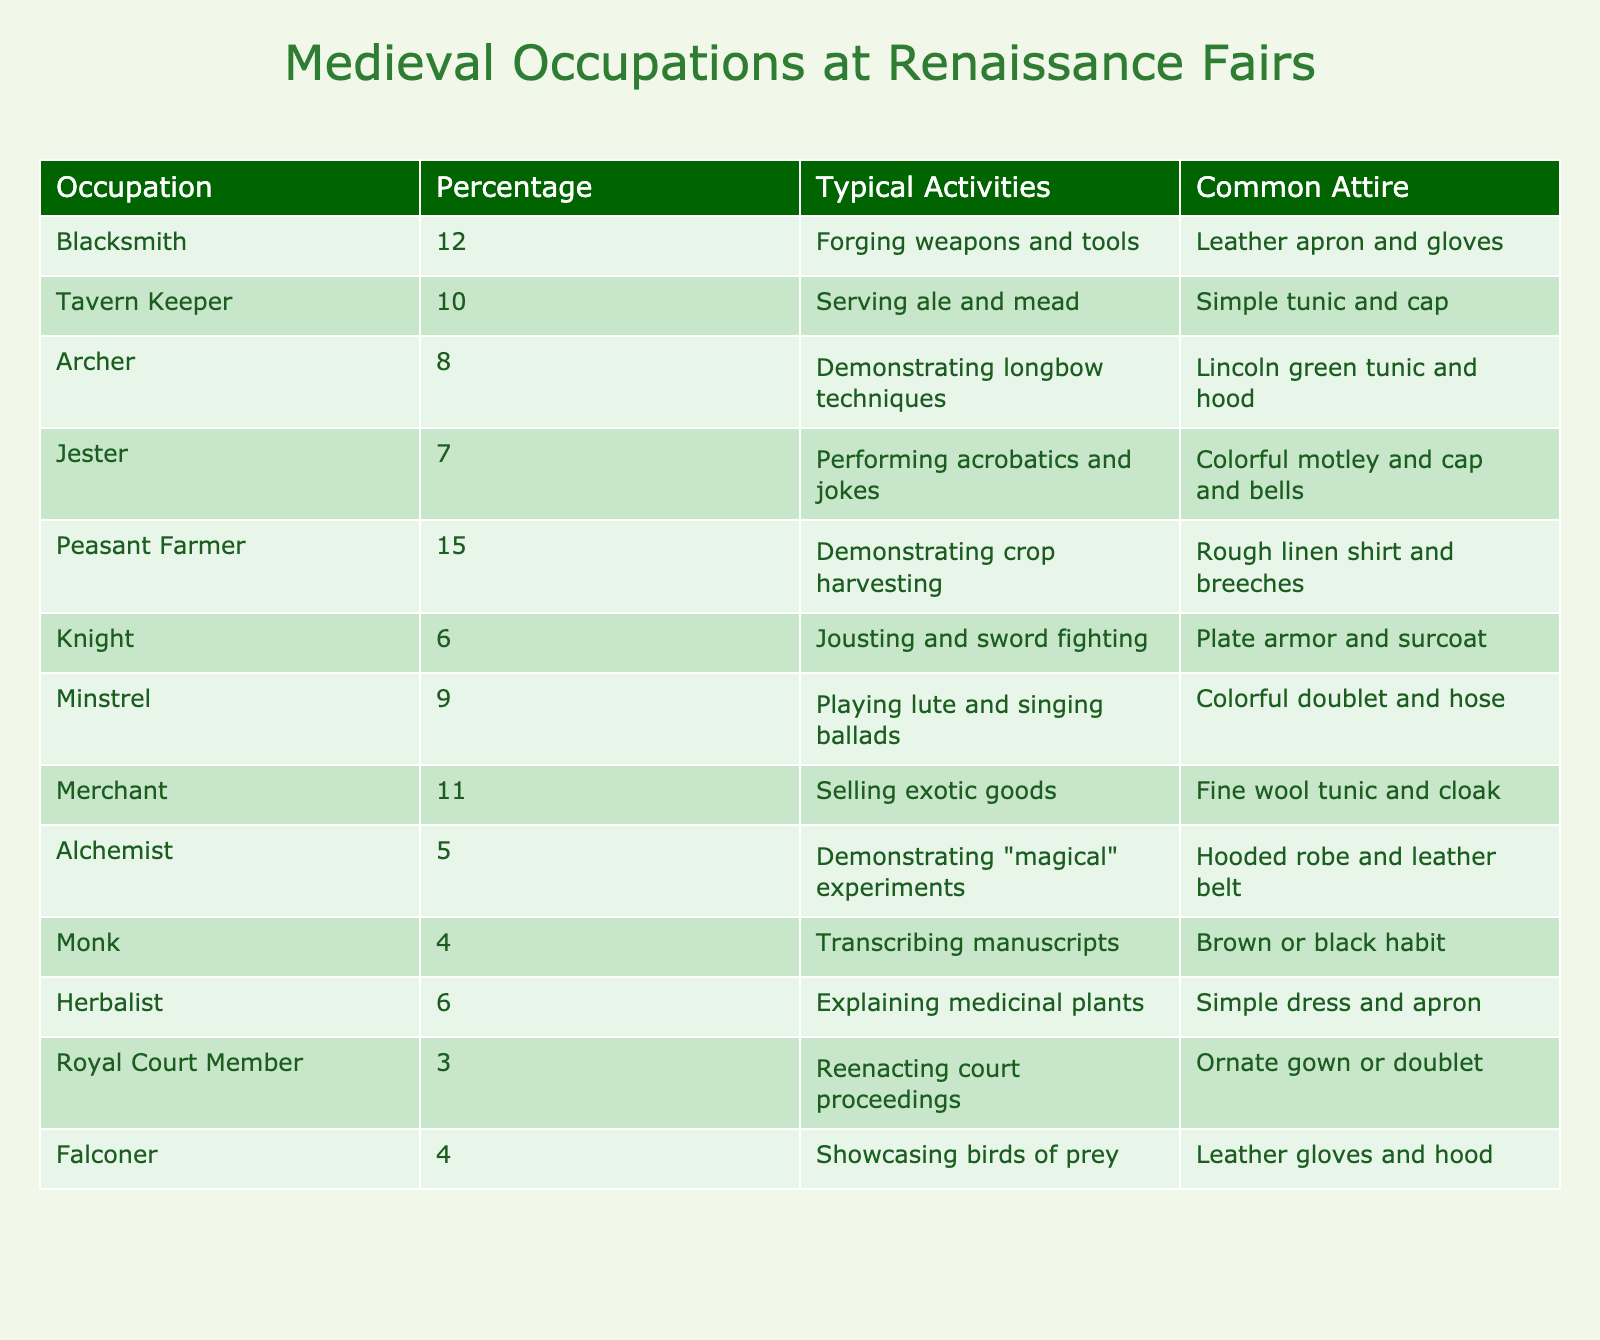What is the percentage of Peasant Farmers represented at Renaissance fairs? According to the table, Peasant Farmers account for 15% of the total occupations represented at Renaissance fairs.
Answer: 15% Which occupation has the highest percentage representation? The occupation with the highest percentage representation is Peasant Farmer, with 15%.
Answer: Peasant Farmer Is the percentage of Knights higher than that of Jesters? Knights have a representation of 6%, while Jesters represent 7%. Since 6% is less than 7%, this statement is false.
Answer: No What is the total percentage of occupations related to performing arts (Minstrel, Jester)? To find this, we add the percentages of Minstrels (9%) and Jesters (7%): 9 + 7 = 16%.
Answer: 16% How many more percent of Blacksmiths are there compared to Alchemists? The percentage of Blacksmiths is 12% and for Alchemists, it's 5%. The difference is 12 - 5 = 7%.
Answer: 7% If we group all occupations that participate in demonstrations (Archer, Blacksmith, Peasant Farmer, Herbalist), what would their combined percentage be? Adding the percentages: Archer (8%) + Blacksmith (12%) + Peasant Farmer (15%) + Herbalist (6%) gives us a total of 41%.
Answer: 41% What is the combined percentage of occupations wearing some form of hood (Archer, Alchemist, Falconer)? The percentages are Archer (8%), Alchemist (5%), and Falconer (4%). Adding these gives us 8 + 5 + 4 = 17%.
Answer: 17% Are Royal Court Members more common than Monks? Royal Court Members have a representation of 3%, while Monks have 4%. Since 3% is less than 4%, this statement is false.
Answer: No What is the percentage of occupations involved in agriculture (Peasant Farmer, Herbalist)? The percentages for these occupations are Peasant Farmer (15%) and Herbalist (6%). Adding them gives us 15 + 6 = 21%.
Answer: 21% Which occupations together form 25% or more when combined? By evaluating various combinations, we find that Blacksmith (12%) and Merchant (11%) combine to give us 23%, and Peasant Farmer (15%) and Jester (7%) combine for 22%. The only combination achieving over 25% is Peasant Farmer (15%) and Blacksmith (12%) with a total of 27%.
Answer: Peasant Farmer and Blacksmith 